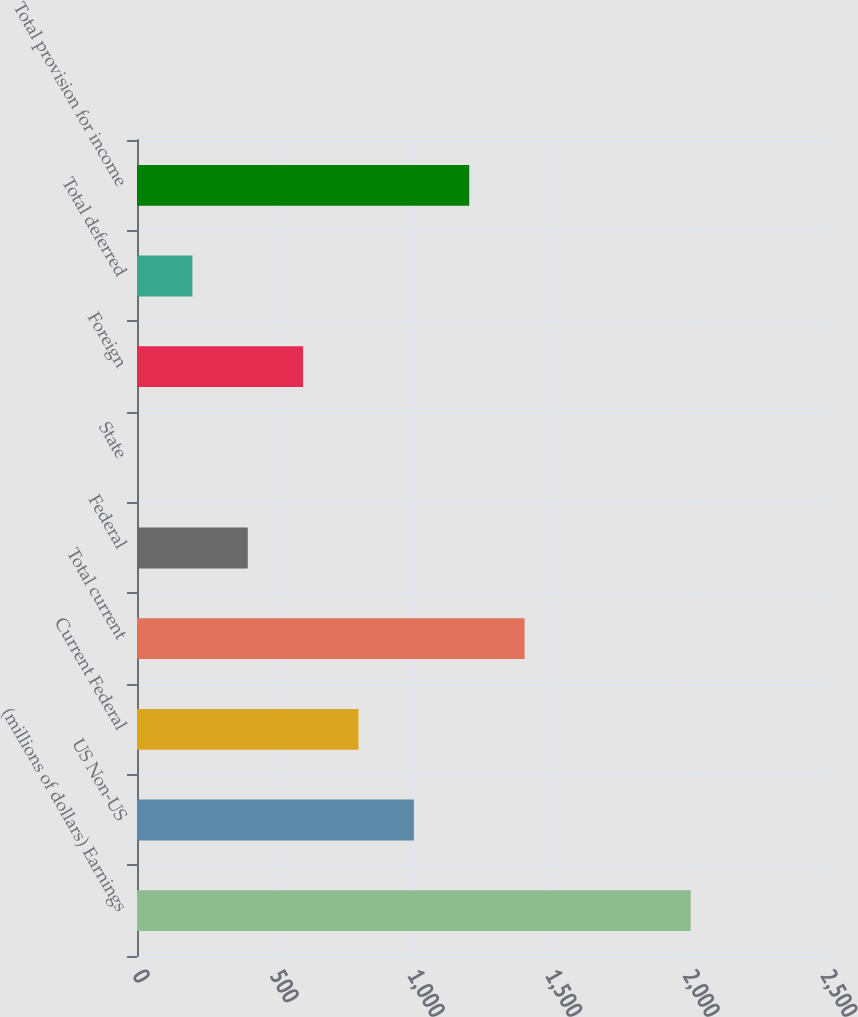Convert chart. <chart><loc_0><loc_0><loc_500><loc_500><bar_chart><fcel>(millions of dollars) Earnings<fcel>US Non-US<fcel>Current Federal<fcel>Total current<fcel>Federal<fcel>State<fcel>Foreign<fcel>Total deferred<fcel>Total provision for income<nl><fcel>2012<fcel>1006.05<fcel>804.86<fcel>1408.43<fcel>402.48<fcel>0.1<fcel>603.67<fcel>201.29<fcel>1207.24<nl></chart> 